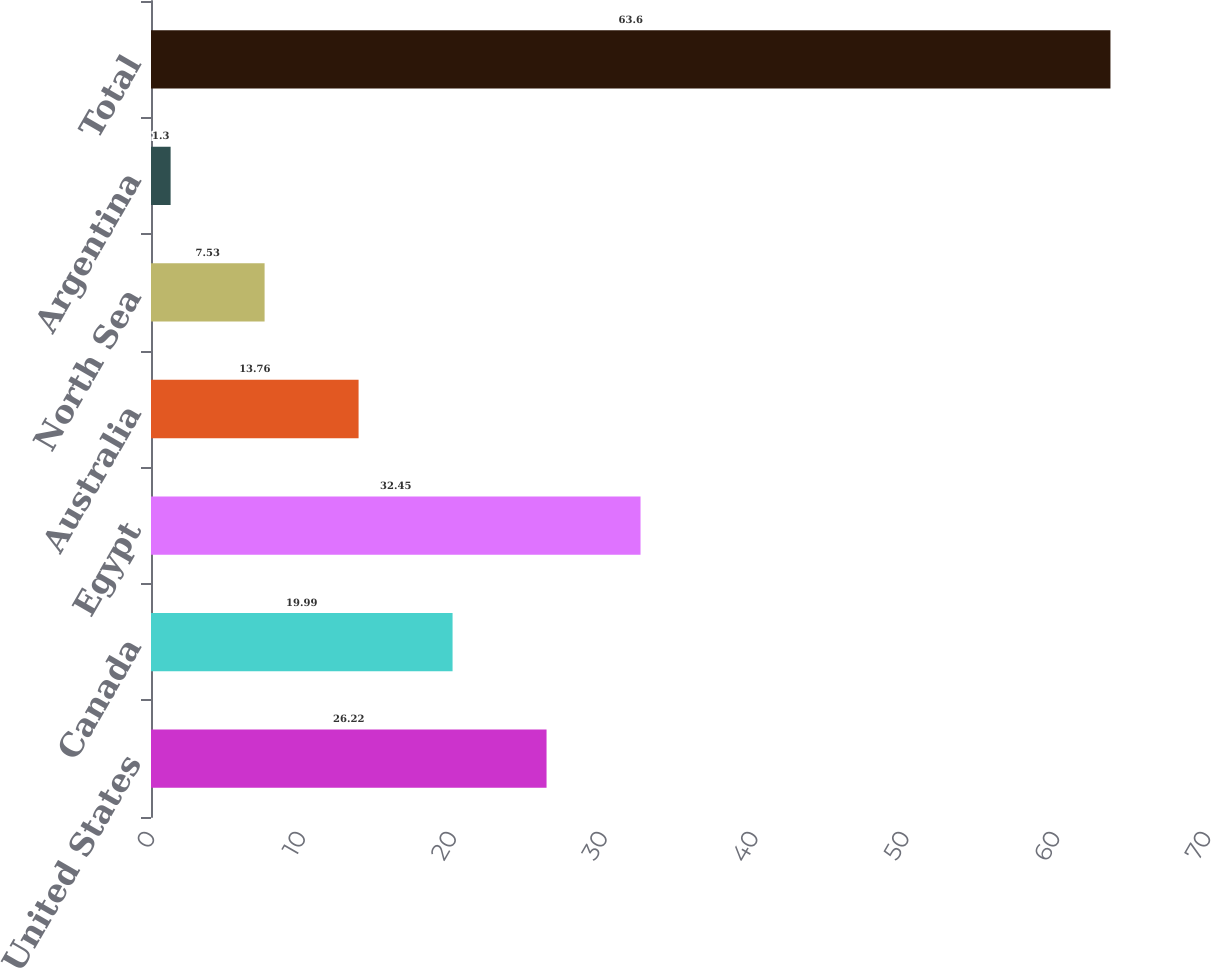Convert chart. <chart><loc_0><loc_0><loc_500><loc_500><bar_chart><fcel>United States<fcel>Canada<fcel>Egypt<fcel>Australia<fcel>North Sea<fcel>Argentina<fcel>Total<nl><fcel>26.22<fcel>19.99<fcel>32.45<fcel>13.76<fcel>7.53<fcel>1.3<fcel>63.6<nl></chart> 